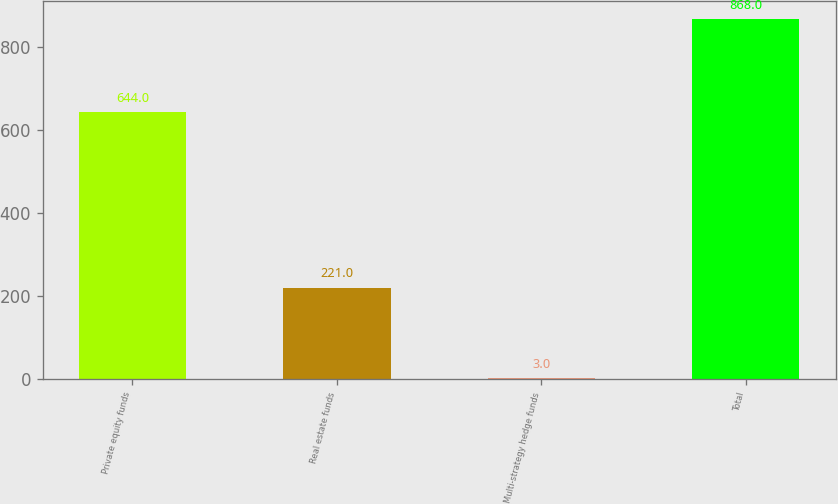Convert chart. <chart><loc_0><loc_0><loc_500><loc_500><bar_chart><fcel>Private equity funds<fcel>Real estate funds<fcel>Multi-strategy hedge funds<fcel>Total<nl><fcel>644<fcel>221<fcel>3<fcel>868<nl></chart> 